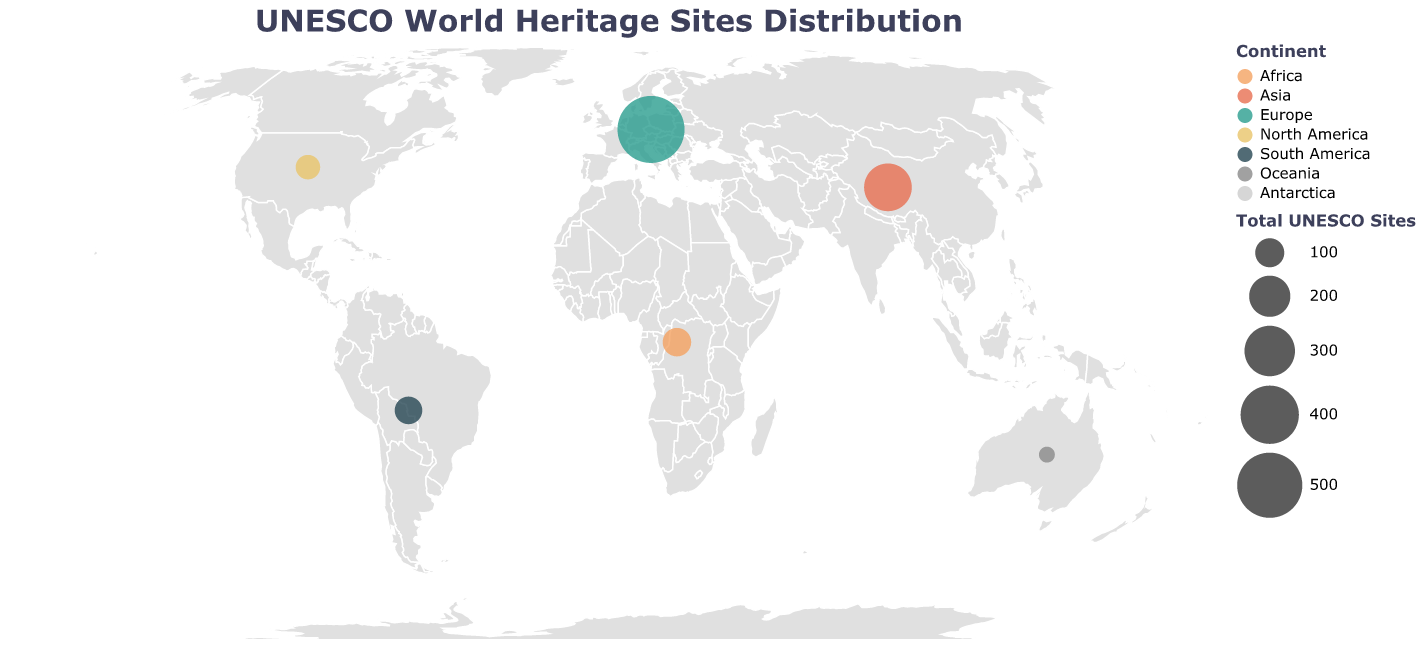What is the title of the figure? The title is located at the top of the figure and generally serves as a description of the overall content. In this case, it reads "UNESCO World Heritage Sites Distribution."
Answer: UNESCO World Heritage Sites Distribution Which continent has the highest number of total UNESCO sites? To determine this, we look for the largest circle on the map, and from the tooltip or legend, it corresponds to Europe with 529 total sites.
Answer: Europe How many natural sites are there in North America? To answer this, we refer to the tooltip for North America, which shows that there are 26 natural sites.
Answer: 26 Compare the number of mixed sites in South America to that in Oceania. Which one has more? By examining the tooltip for both continents, we see that South America has 7 mixed sites, while Oceania has 4. Therefore, South America has more mixed sites.
Answer: South America Which continent has no UNESCO World Heritage Sites? By observing the figure and the tooltips, it's evident that Antarctica has zero sites, indicated by the absence of any circle for that region.
Answer: Antarctica What is the notable site for children in Africa? The notable site for children in Africa can be found by checking the tooltip for Africa, which lists "Serengeti National Park."
Answer: Serengeti National Park What is the total number of cultural sites in Asia and Europe combined? From the tooltips, we can see that Asia has 189 cultural sites and Europe has 453. Summing these up gives 189 + 453 = 642.
Answer: 642 How does the number of cultural sites in Asia compare to the total sites in North America? Asia has 189 cultural sites and North America's total sites count is 71; thus, Asia has more cultural sites than the total number of sites in North America.
Answer: Asia has more cultural sites Which continent has the smallest number of total UNESCO sites and what is the notable site for children there? The tooltip for each continent indicates that Oceania has the smallest number of total sites at 30, and the notable site for children is the Great Barrier Reef.
Answer: Oceania, Great Barrier Reef What do the colors in the figure represent? The colors in the figure represent different continents, as indicated by the color legend to the right of the map.
Answer: Different continents 